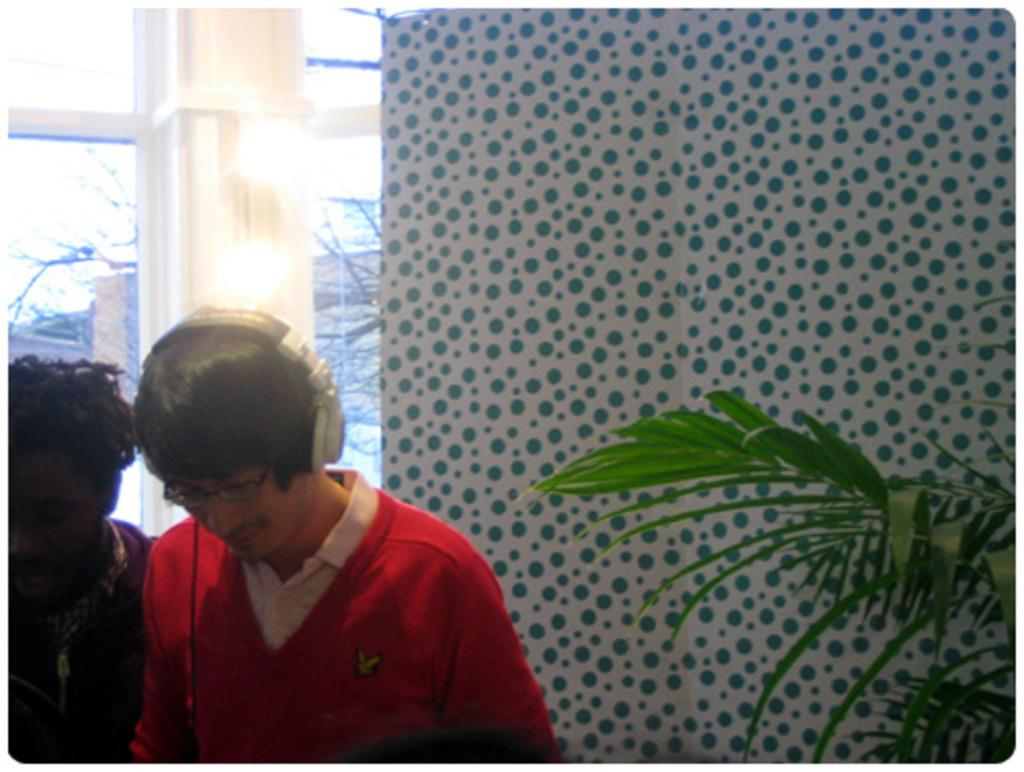How many people are visible on the left side of the image? There are two persons on the left side of the image. What can be seen in the background of the image? There is a wall, a glass window, a pillar, and a plant in the background of the image. What type of soda is being served in the image? There is no soda present in the image. What action are the two persons performing in the image? The provided facts do not specify any actions being performed by the two persons in the image. 